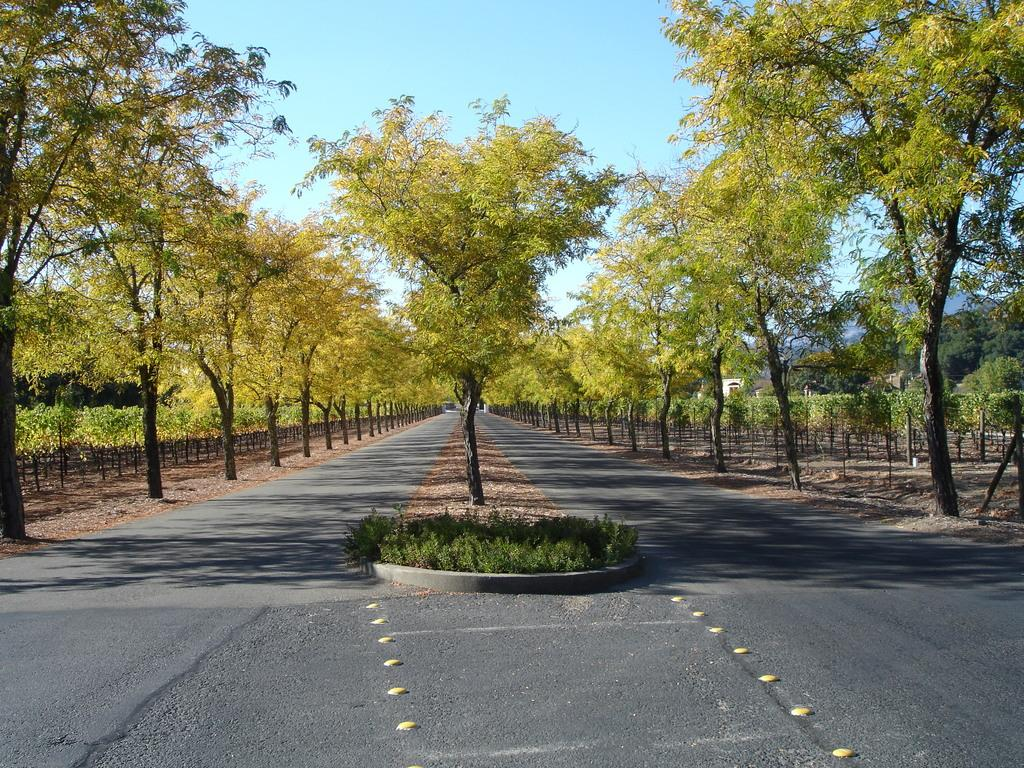What type of vegetation can be seen in the image? There are trees in the image. What can be seen running through the trees in the image? There is a road in the image. What is visible above the trees and road in the image? The sky is visible in the image. How many chairs can be seen in the image? There are no chairs present in the image. Is it raining in the image? There is no indication of rain in the image; only trees, a road, and the sky are visible. 